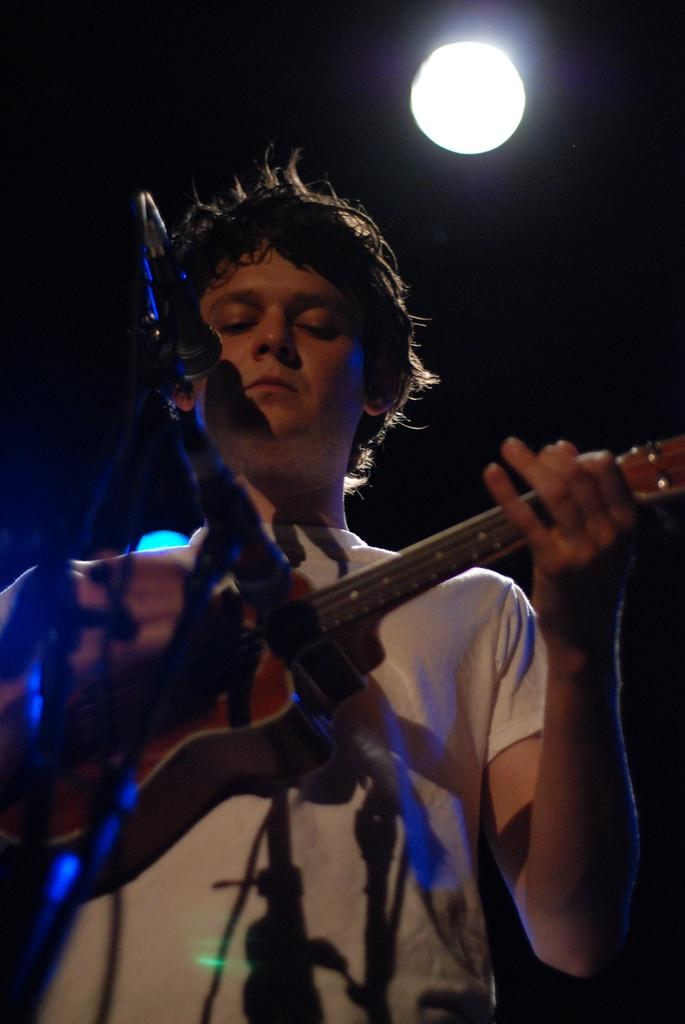What is the man in the image doing? The man is playing a guitar. What object is the man positioned in front of? The man is in front of a microphone. Can you describe the background of the image? There is a light in the background of the image. How many pigs can be seen in the image? There are no pigs present in the image. What type of steam is coming from the guitar in the image? There is no steam coming from the guitar in the image. 